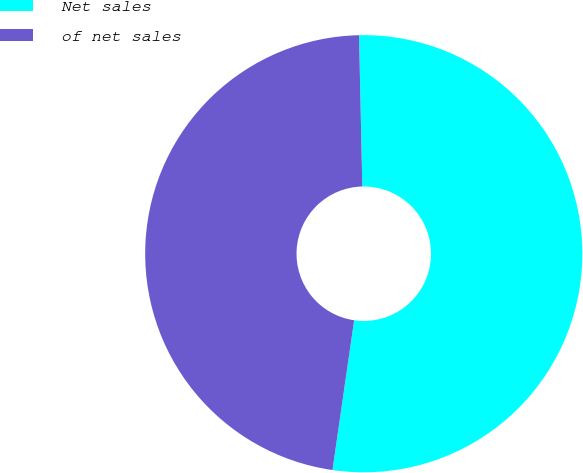Convert chart. <chart><loc_0><loc_0><loc_500><loc_500><pie_chart><fcel>Net sales<fcel>of net sales<nl><fcel>52.63%<fcel>47.37%<nl></chart> 